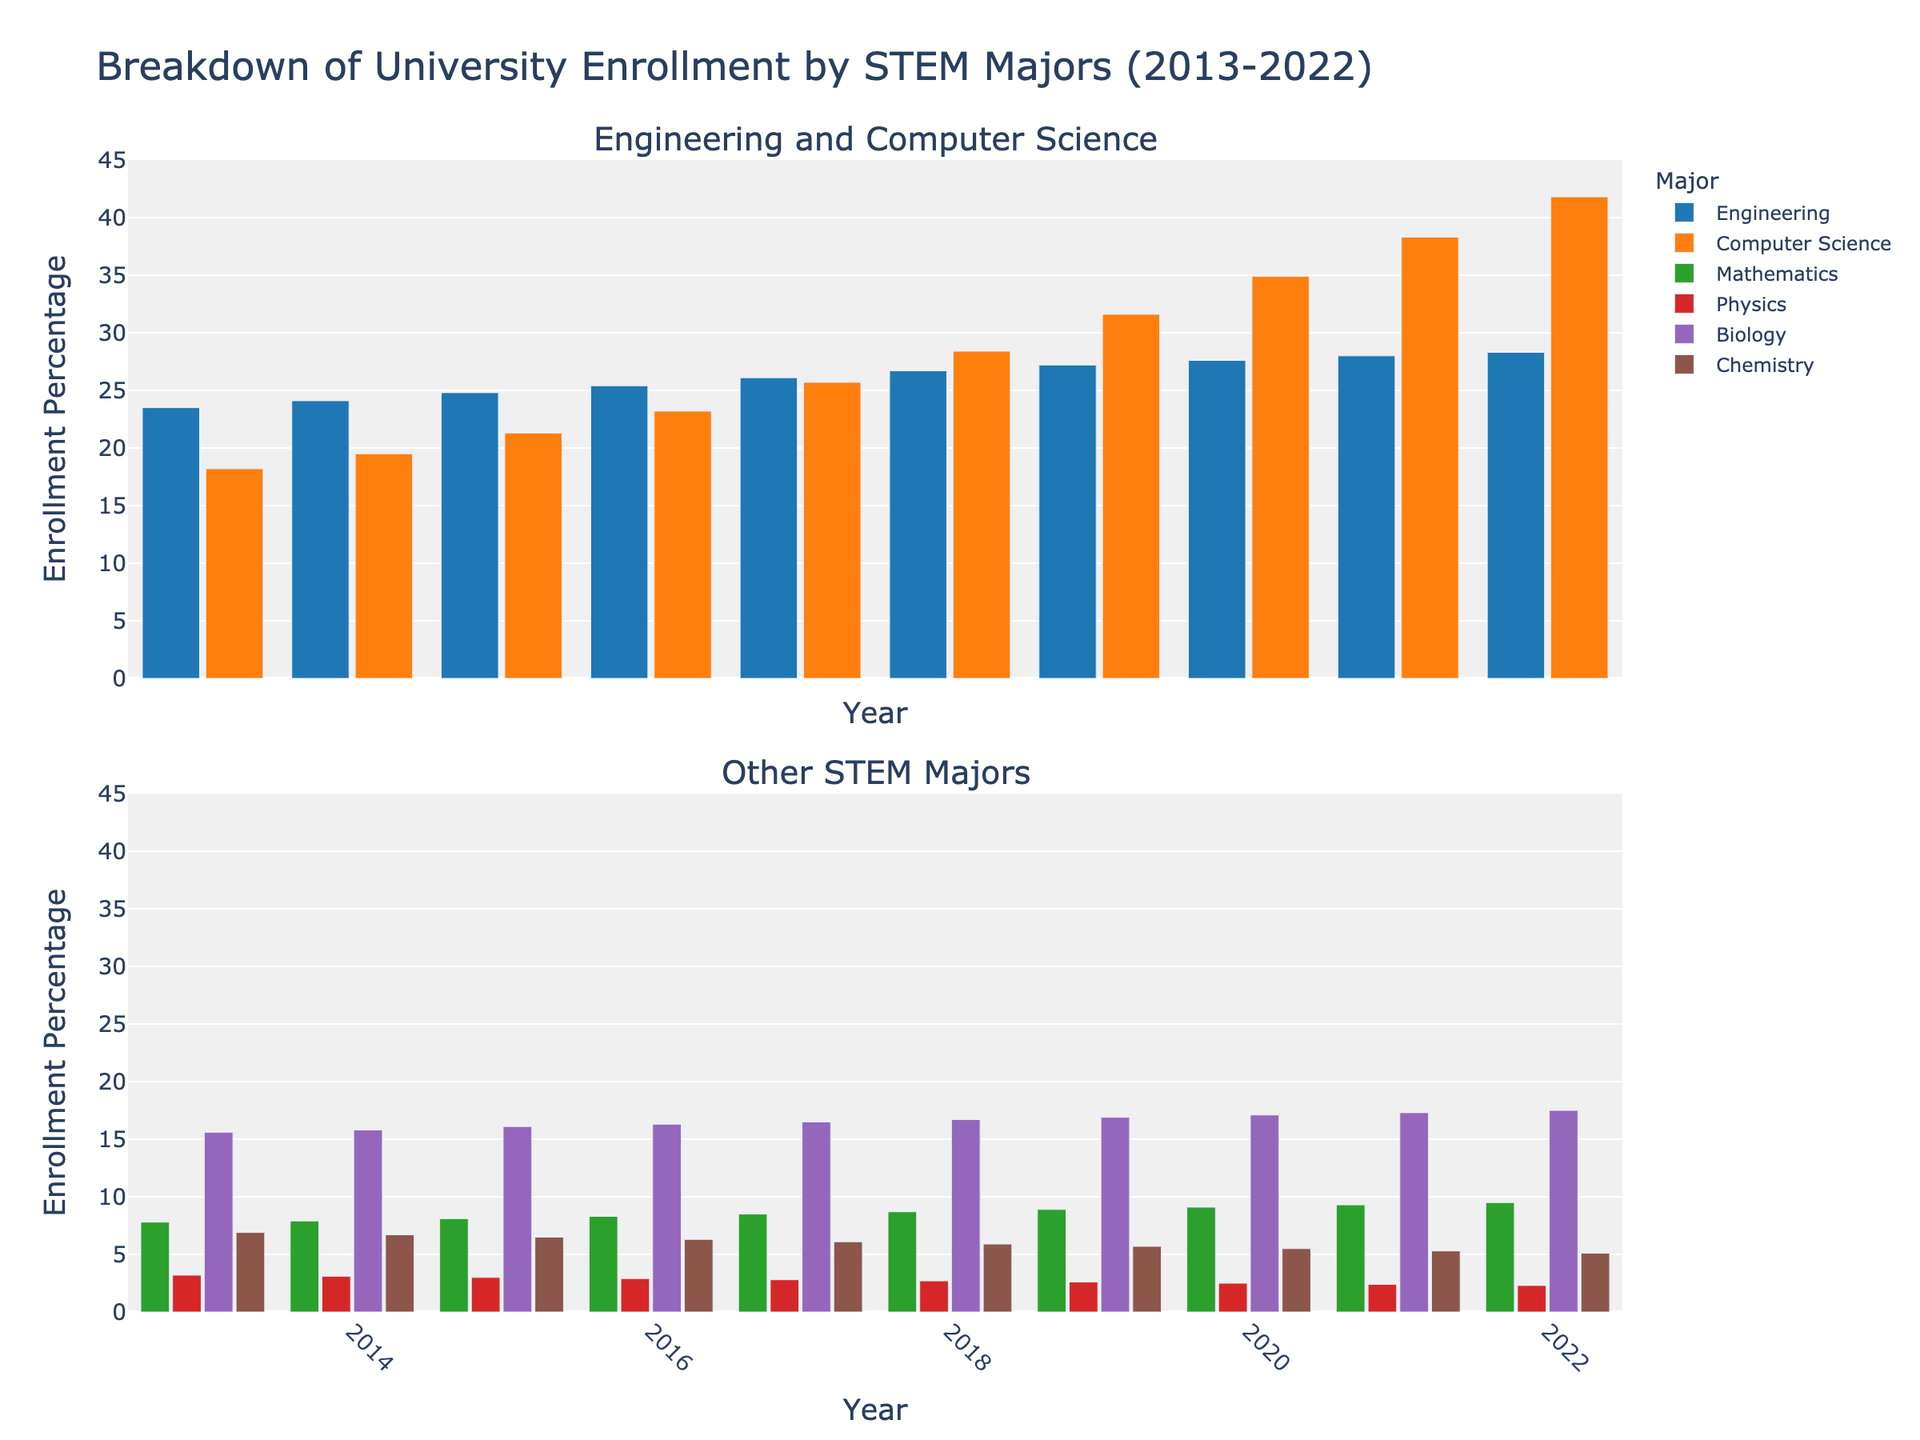What's the overall trend of university enrollment in Engineering from 2013 to 2022? Examine the heights of the bars for Engineering from 2013 to 2022. They consistently increase over the years, indicating a positive trend.
Answer: Increasing trend In which year did Computer Science enrollment surpass Engineering enrollment for the first time? Look at the height of the bars for Computer Science and Engineering. In 2021, the bar for Computer Science is taller than the one for Engineering for the first time.
Answer: 2021 Between 2013 and 2022, which year had the highest overall enrollment percentage in the "Other STEM Majors" group? Compare the heights of bars representing Mathematics, Physics, Biology, and Chemistry across all years. 2022 has the highest sum of bar heights in this group.
Answer: 2022 How much did the enrollment percentage for Biology change from 2013 to 2022? Subtract the enrollment percentage for Biology in 2013 from the percentage in 2022: 17.5% - 15.6% = 1.9%.
Answer: Increased by 1.9% Which major showed a consistent decrease in enrollment percentage from 2013 to 2022? Observe the heights of the bars for each major. Physics shows a consistent decrease in enrollment percentage over these years.
Answer: Physics By how much did the sum of enrollment percentages for Engineering and Computer Science change between 2013 and 2022? Calculate the sum for each year and find the difference: (28.3% + 41.8%) - (23.5% + 18.2%) = 70.1% - 41.7% = 28.4%.
Answer: Increased by 28.4% Which major had the smallest increase in enrollment percentage from 2013 to 2022? Determine the change for each major and identify the smallest increase. Chemistry changed from 6.9% to 5.1%, which is a decrease. Hence, it had the smallest increase (actually a decrease).
Answer: Chemistry (decreased) Compare the highest enrollment percentage of Computer Science with the highest percentage of Biology. Which one is higher and by how much? The highest percentage for Computer Science is 41.8% in 2022, and for Biology, it is 17.5% in 2022. Subtract the two percentages: 41.8% - 17.5% = 24.3%.
Answer: Computer Science by 24.3% Which two majors' enrollment percentages were closest to each other in 2013? Look at the bar heights for all majors in 2013 and find the smallest difference. Mathematics at 7.8% and Chemistry at 6.9% have a difference of 0.9%, which is the smallest.
Answer: Mathematics and Chemistry In which year did Chemistry enrollment percentage drop below the percentage for Mathematics for the first time? Compare the bar heights for Chemistry and Mathematics for each year. In 2016, the Chemistry bar is shorter than the Mathematics bar for the first time.
Answer: 2016 